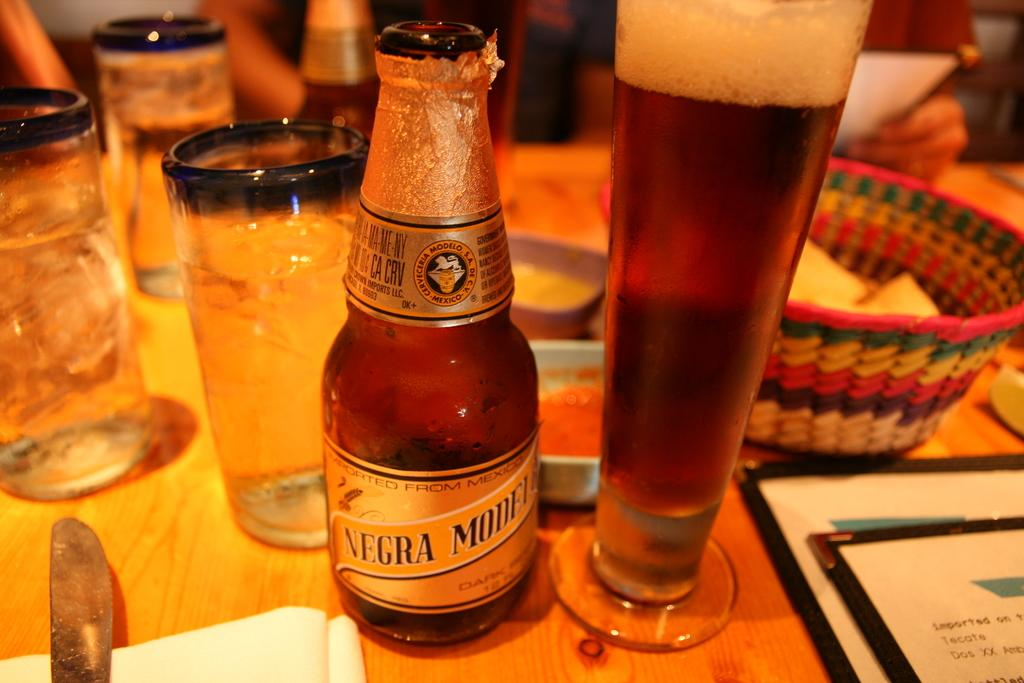<image>
Describe the image concisely. A bottle of Negra Modela sits next to a full glass of beer on a wood table. 